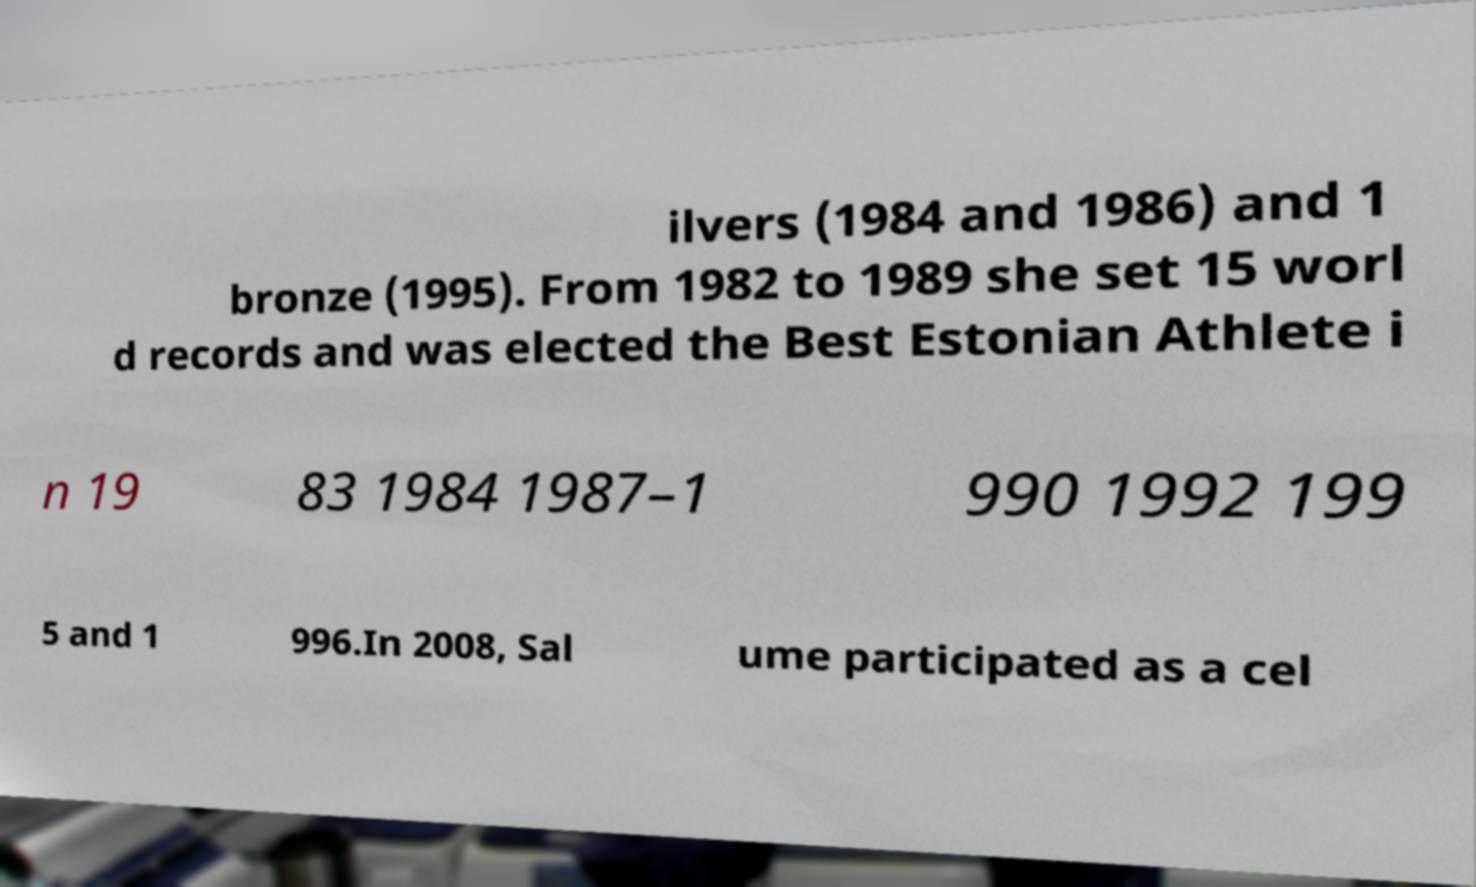Please read and relay the text visible in this image. What does it say? ilvers (1984 and 1986) and 1 bronze (1995). From 1982 to 1989 she set 15 worl d records and was elected the Best Estonian Athlete i n 19 83 1984 1987–1 990 1992 199 5 and 1 996.In 2008, Sal ume participated as a cel 